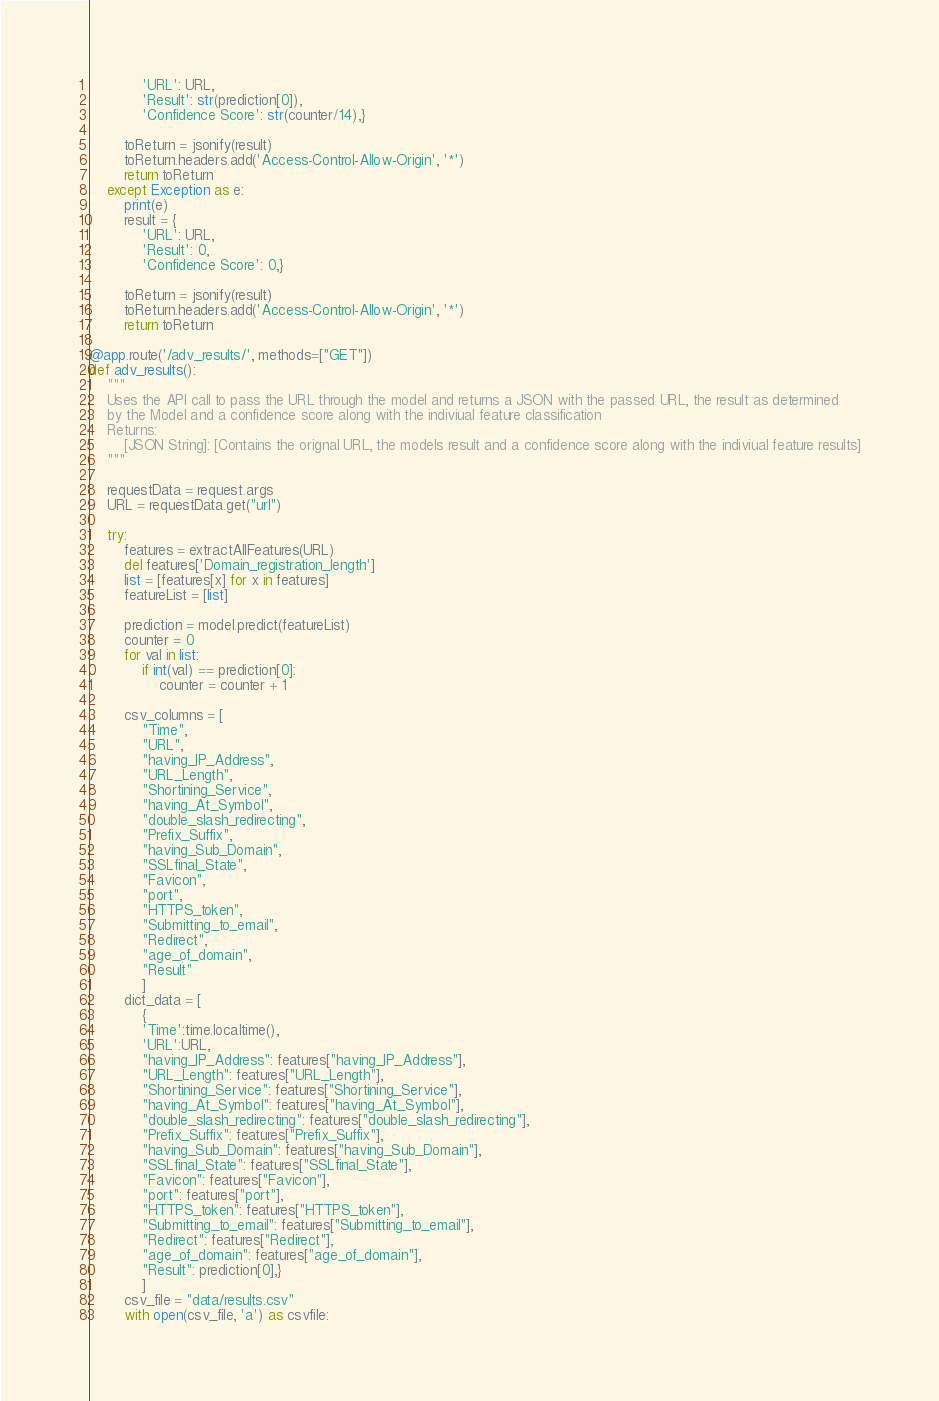<code> <loc_0><loc_0><loc_500><loc_500><_Python_>            'URL': URL,
            'Result': str(prediction[0]),
            'Confidence Score': str(counter/14),}
        
        toReturn = jsonify(result)
        toReturn.headers.add('Access-Control-Allow-Origin', '*')
        return toReturn
    except Exception as e:
        print(e)
        result = {
            'URL': URL,
            'Result': 0,
            'Confidence Score': 0,}
        
        toReturn = jsonify(result)
        toReturn.headers.add('Access-Control-Allow-Origin', '*')
        return toReturn

@app.route('/adv_results/', methods=["GET"])
def adv_results():
    """
    Uses the API call to pass the URL through the model and returns a JSON with the passed URL, the result as determined 
    by the Model and a confidence score along with the indiviual feature classification
    Returns:
        [JSON String]: [Contains the orignal URL, the models result and a confidence score along with the indiviual feature results]
    """

    requestData = request.args
    URL = requestData.get("url")

    try:
        features = extractAllFeatures(URL)
        del features['Domain_registration_length']
        list = [features[x] for x in features]
        featureList = [list]

        prediction = model.predict(featureList)
        counter = 0
        for val in list:
            if int(val) == prediction[0]:
                counter = counter + 1

        csv_columns = [
            "Time",
            "URL",
            "having_IP_Address",
            "URL_Length",
            "Shortining_Service",
            "having_At_Symbol",
            "double_slash_redirecting",
            "Prefix_Suffix",
            "having_Sub_Domain",
            "SSLfinal_State",
            "Favicon",
            "port",
            "HTTPS_token",
            "Submitting_to_email",
            "Redirect",
            "age_of_domain",
            "Result"
            ]
        dict_data = [
            {
            'Time':time.localtime(),
            'URL':URL,         
            "having_IP_Address": features["having_IP_Address"],
            "URL_Length": features["URL_Length"],
            "Shortining_Service": features["Shortining_Service"],
            "having_At_Symbol": features["having_At_Symbol"],
            "double_slash_redirecting": features["double_slash_redirecting"],
            "Prefix_Suffix": features["Prefix_Suffix"],
            "having_Sub_Domain": features["having_Sub_Domain"],
            "SSLfinal_State": features["SSLfinal_State"],
            "Favicon": features["Favicon"],
            "port": features["port"],
            "HTTPS_token": features["HTTPS_token"],
            "Submitting_to_email": features["Submitting_to_email"],
            "Redirect": features["Redirect"],
            "age_of_domain": features["age_of_domain"],
            "Result": prediction[0],}
            ]
        csv_file = "data/results.csv"
        with open(csv_file, 'a') as csvfile:</code> 